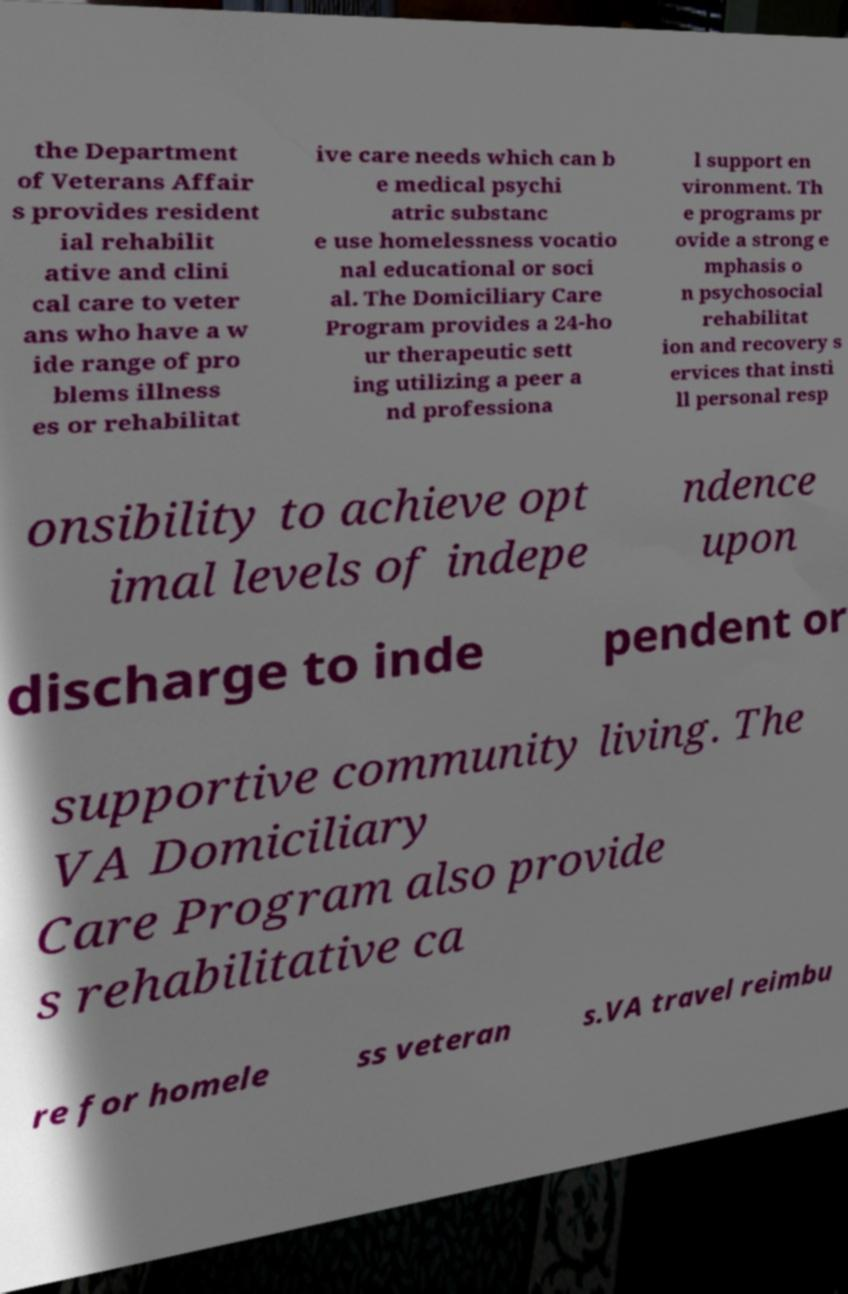Can you accurately transcribe the text from the provided image for me? the Department of Veterans Affair s provides resident ial rehabilit ative and clini cal care to veter ans who have a w ide range of pro blems illness es or rehabilitat ive care needs which can b e medical psychi atric substanc e use homelessness vocatio nal educational or soci al. The Domiciliary Care Program provides a 24-ho ur therapeutic sett ing utilizing a peer a nd professiona l support en vironment. Th e programs pr ovide a strong e mphasis o n psychosocial rehabilitat ion and recovery s ervices that insti ll personal resp onsibility to achieve opt imal levels of indepe ndence upon discharge to inde pendent or supportive community living. The VA Domiciliary Care Program also provide s rehabilitative ca re for homele ss veteran s.VA travel reimbu 